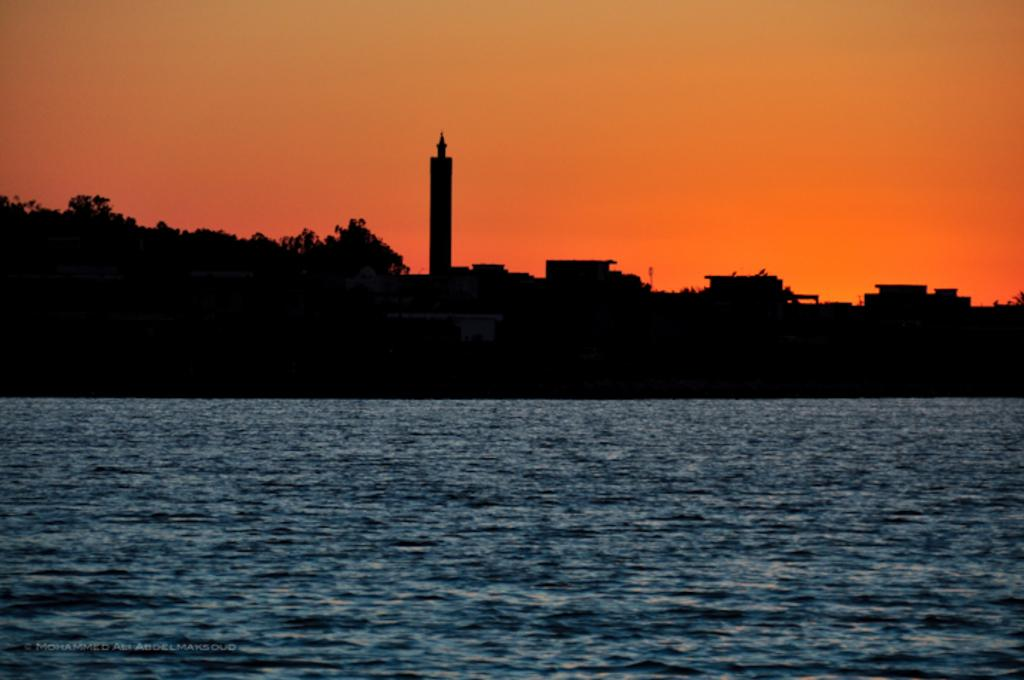What is visible in the image? Water, trees, and buildings are visible in the image. Can you describe the water in the image? The water is visible, but its specific characteristics are not mentioned in the facts. What type of vegetation can be seen in the image? Trees are present in the image. What structures are visible in the image? Buildings are visible in the image. How many vans are driving on the water in the image? There are no vans or driving activity present in the image. What direction do the trees turn in the image? The trees do not turn in any specific direction in the image; they are stationary. 